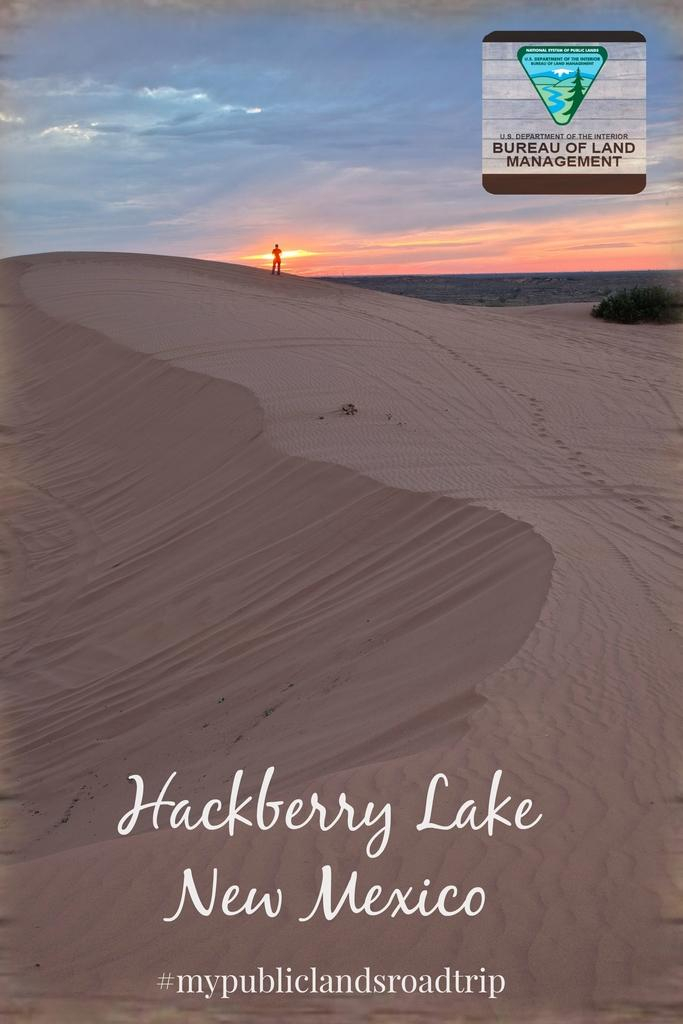Provide a one-sentence caption for the provided image. The pamphlet is distributed by the Bureau of Land Management. 